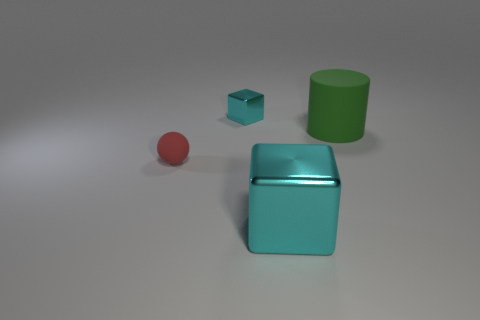Add 3 small cyan metallic objects. How many objects exist? 7 Subtract all yellow blocks. Subtract all brown spheres. How many blocks are left? 2 Subtract all spheres. How many objects are left? 3 Add 3 red rubber balls. How many red rubber balls exist? 4 Subtract 0 red cubes. How many objects are left? 4 Subtract all yellow cylinders. Subtract all small matte spheres. How many objects are left? 3 Add 4 large cubes. How many large cubes are left? 5 